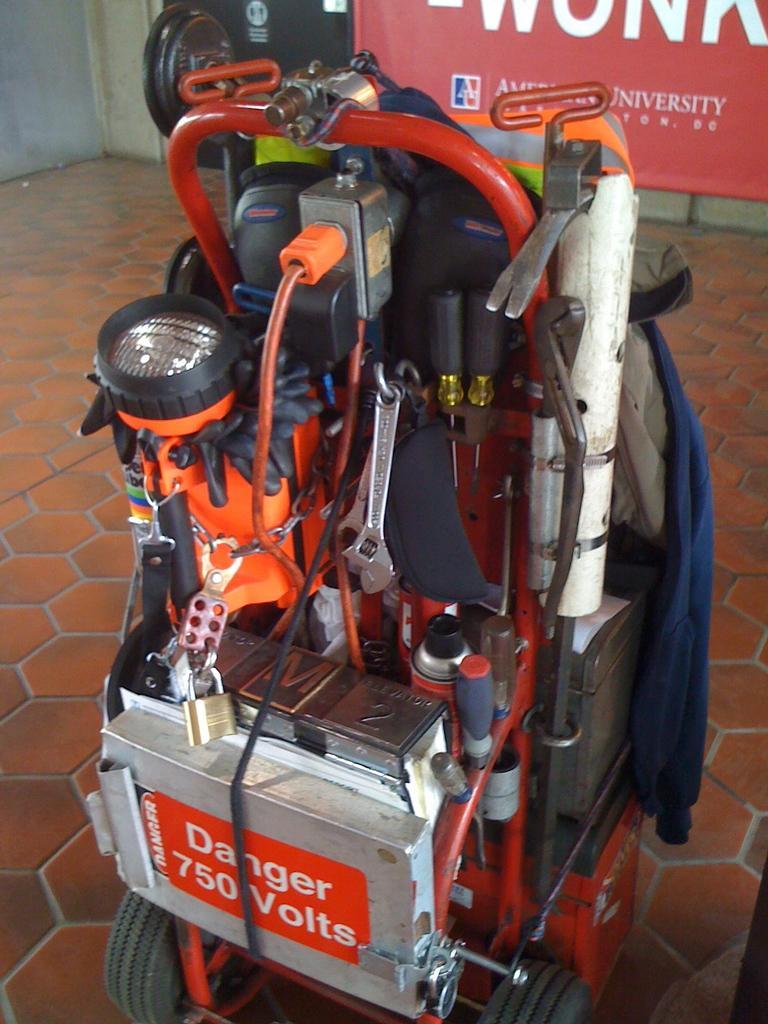Please provide a concise description of this image. In this image there is a machine on the ground, there is a red color banner behind the machine, there is a wall. 